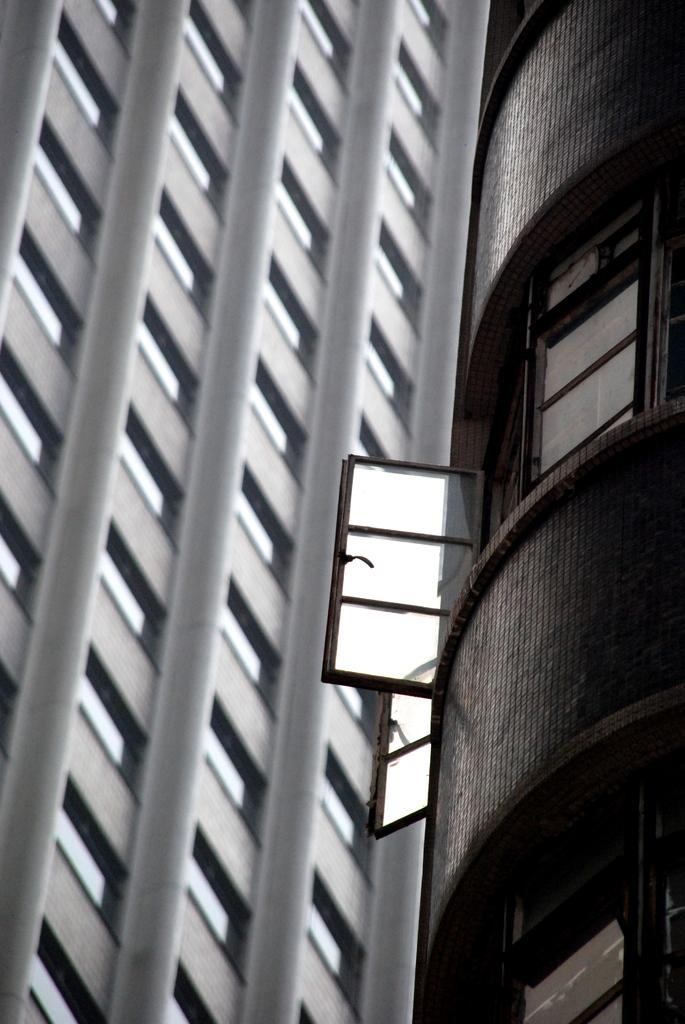What type of structure is visible in the image? There is a building in the image. What feature can be seen on the building? The building has glass doors. Are there any slaves visible in the image? There is no mention of slaves in the provided facts, and therefore there is no indication of their presence in the image. 